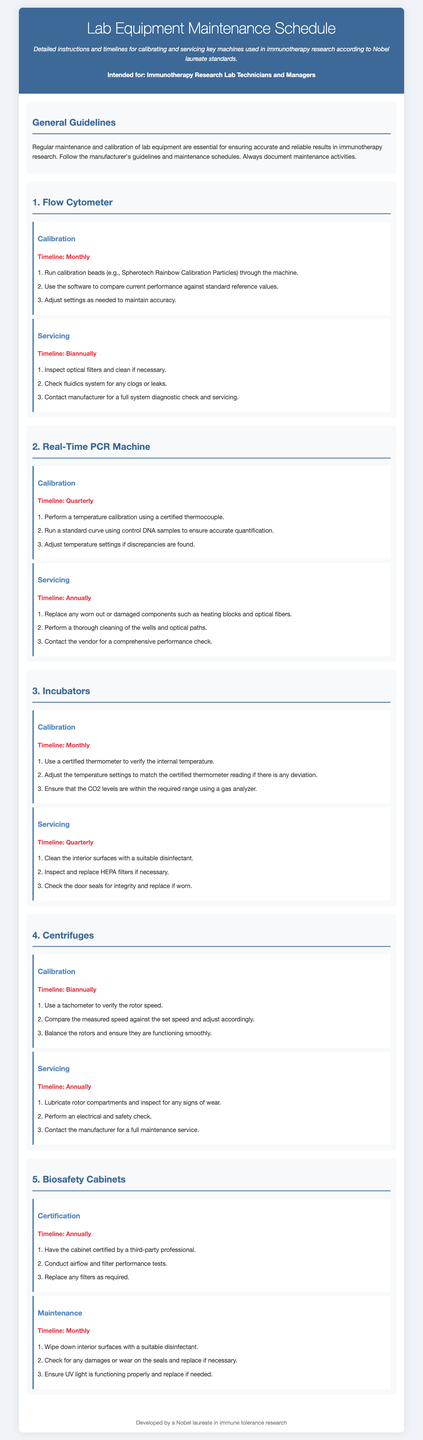what is the timeline for Flow Cytometer calibration? The timeline for Flow Cytometer calibration is specified in the document.
Answer: Monthly how often should the Real-Time PCR Machine be serviced? The servicing frequency for the Real-Time PCR Machine is provided in the maintenance schedule.
Answer: Annually what component should be replaced in Real-Time PCR Machine servicing? This component is mentioned under the servicing section for the Real-Time PCR Machine.
Answer: Heating blocks what is the recommended calibration method for Incubators? The calibration method for Incubators is outlined in the calibration instructions.
Answer: Use a certified thermometer how many times per year are Biosafety Cabinets to be certified? The document explicitly states the frequency of certification for Biosafety Cabinets.
Answer: Annually what maintenance action should be taken for Centrifuges? The document describes maintenance actions required for Centrifuges.
Answer: Lubricate rotor compartments what is the timeline for the maintenance of Biosafety Cabinets? The timeline for the maintenance of Biosafety Cabinets is provided in the maintenance schedule.
Answer: Monthly what should be inspected during Flow Cytometer servicing? The document specifies the items that need to be inspected during servicing.
Answer: Optical filters where can you find the calibration timeline for Incubators? The calibration timeline is located in the relevant section for Incubators in the document.
Answer: Monthly 